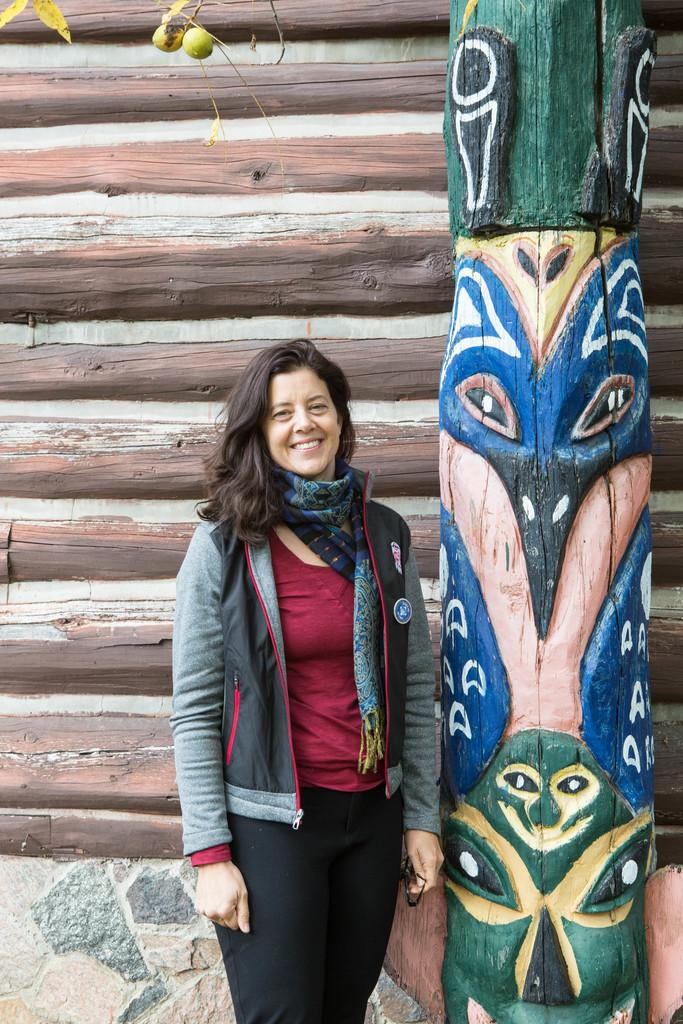What is the main subject of the image? The main subject of the image is a woman standing in the middle. What is the woman doing in the image? The woman is smiling in the image. What can be seen beside the woman? There is a painting on a wooden board beside the woman. What is visible behind the woman? There is a wall visible behind the woman. How many bears can be seen biting the woman's arm in the image? There are no bears or biting actions present in the image. 